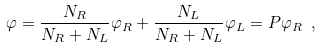<formula> <loc_0><loc_0><loc_500><loc_500>\varphi = \frac { N _ { R } } { N _ { R } + N _ { L } } \varphi _ { R } + \frac { N _ { L } } { N _ { R } + N _ { L } } \varphi _ { L } = P \varphi _ { R } \ ,</formula> 